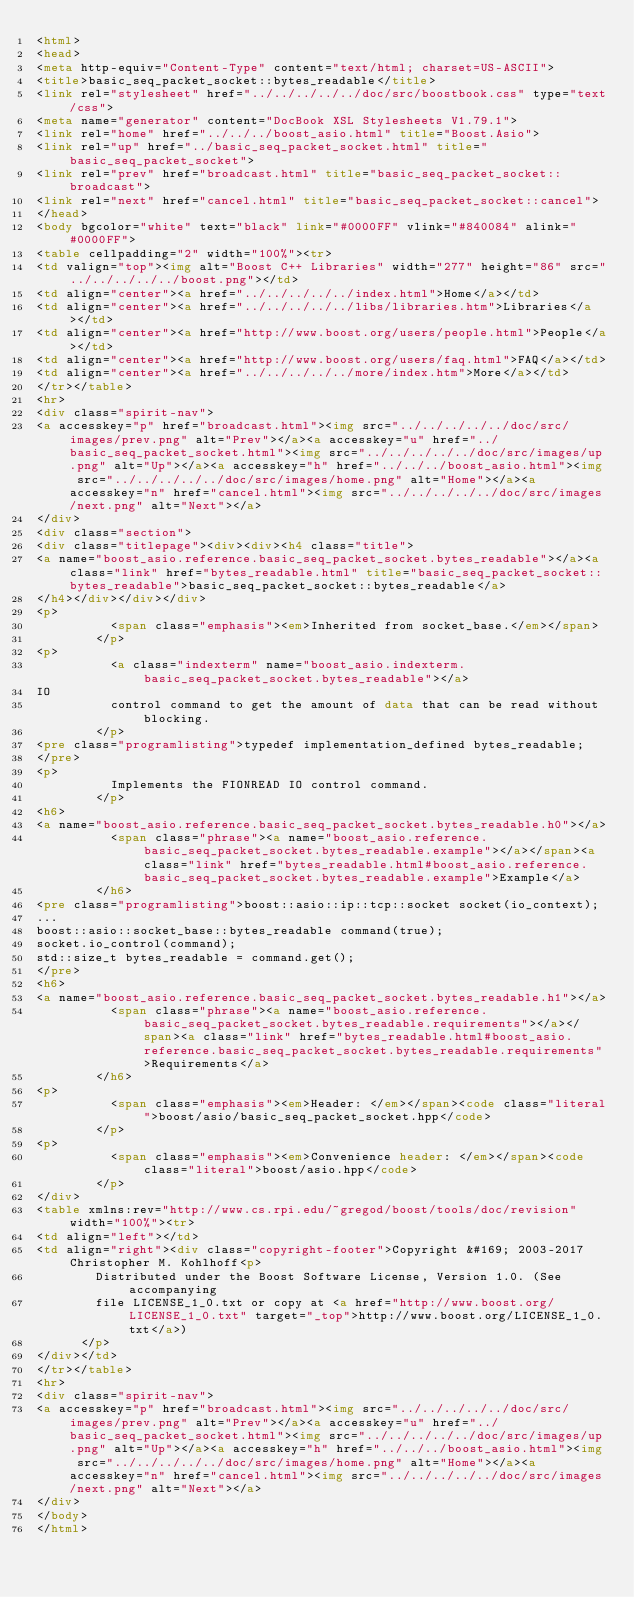<code> <loc_0><loc_0><loc_500><loc_500><_HTML_><html>
<head>
<meta http-equiv="Content-Type" content="text/html; charset=US-ASCII">
<title>basic_seq_packet_socket::bytes_readable</title>
<link rel="stylesheet" href="../../../../../doc/src/boostbook.css" type="text/css">
<meta name="generator" content="DocBook XSL Stylesheets V1.79.1">
<link rel="home" href="../../../boost_asio.html" title="Boost.Asio">
<link rel="up" href="../basic_seq_packet_socket.html" title="basic_seq_packet_socket">
<link rel="prev" href="broadcast.html" title="basic_seq_packet_socket::broadcast">
<link rel="next" href="cancel.html" title="basic_seq_packet_socket::cancel">
</head>
<body bgcolor="white" text="black" link="#0000FF" vlink="#840084" alink="#0000FF">
<table cellpadding="2" width="100%"><tr>
<td valign="top"><img alt="Boost C++ Libraries" width="277" height="86" src="../../../../../boost.png"></td>
<td align="center"><a href="../../../../../index.html">Home</a></td>
<td align="center"><a href="../../../../../libs/libraries.htm">Libraries</a></td>
<td align="center"><a href="http://www.boost.org/users/people.html">People</a></td>
<td align="center"><a href="http://www.boost.org/users/faq.html">FAQ</a></td>
<td align="center"><a href="../../../../../more/index.htm">More</a></td>
</tr></table>
<hr>
<div class="spirit-nav">
<a accesskey="p" href="broadcast.html"><img src="../../../../../doc/src/images/prev.png" alt="Prev"></a><a accesskey="u" href="../basic_seq_packet_socket.html"><img src="../../../../../doc/src/images/up.png" alt="Up"></a><a accesskey="h" href="../../../boost_asio.html"><img src="../../../../../doc/src/images/home.png" alt="Home"></a><a accesskey="n" href="cancel.html"><img src="../../../../../doc/src/images/next.png" alt="Next"></a>
</div>
<div class="section">
<div class="titlepage"><div><div><h4 class="title">
<a name="boost_asio.reference.basic_seq_packet_socket.bytes_readable"></a><a class="link" href="bytes_readable.html" title="basic_seq_packet_socket::bytes_readable">basic_seq_packet_socket::bytes_readable</a>
</h4></div></div></div>
<p>
          <span class="emphasis"><em>Inherited from socket_base.</em></span>
        </p>
<p>
          <a class="indexterm" name="boost_asio.indexterm.basic_seq_packet_socket.bytes_readable"></a> 
IO
          control command to get the amount of data that can be read without blocking.
        </p>
<pre class="programlisting">typedef implementation_defined bytes_readable;
</pre>
<p>
          Implements the FIONREAD IO control command.
        </p>
<h6>
<a name="boost_asio.reference.basic_seq_packet_socket.bytes_readable.h0"></a>
          <span class="phrase"><a name="boost_asio.reference.basic_seq_packet_socket.bytes_readable.example"></a></span><a class="link" href="bytes_readable.html#boost_asio.reference.basic_seq_packet_socket.bytes_readable.example">Example</a>
        </h6>
<pre class="programlisting">boost::asio::ip::tcp::socket socket(io_context);
...
boost::asio::socket_base::bytes_readable command(true);
socket.io_control(command);
std::size_t bytes_readable = command.get();
</pre>
<h6>
<a name="boost_asio.reference.basic_seq_packet_socket.bytes_readable.h1"></a>
          <span class="phrase"><a name="boost_asio.reference.basic_seq_packet_socket.bytes_readable.requirements"></a></span><a class="link" href="bytes_readable.html#boost_asio.reference.basic_seq_packet_socket.bytes_readable.requirements">Requirements</a>
        </h6>
<p>
          <span class="emphasis"><em>Header: </em></span><code class="literal">boost/asio/basic_seq_packet_socket.hpp</code>
        </p>
<p>
          <span class="emphasis"><em>Convenience header: </em></span><code class="literal">boost/asio.hpp</code>
        </p>
</div>
<table xmlns:rev="http://www.cs.rpi.edu/~gregod/boost/tools/doc/revision" width="100%"><tr>
<td align="left"></td>
<td align="right"><div class="copyright-footer">Copyright &#169; 2003-2017 Christopher M. Kohlhoff<p>
        Distributed under the Boost Software License, Version 1.0. (See accompanying
        file LICENSE_1_0.txt or copy at <a href="http://www.boost.org/LICENSE_1_0.txt" target="_top">http://www.boost.org/LICENSE_1_0.txt</a>)
      </p>
</div></td>
</tr></table>
<hr>
<div class="spirit-nav">
<a accesskey="p" href="broadcast.html"><img src="../../../../../doc/src/images/prev.png" alt="Prev"></a><a accesskey="u" href="../basic_seq_packet_socket.html"><img src="../../../../../doc/src/images/up.png" alt="Up"></a><a accesskey="h" href="../../../boost_asio.html"><img src="../../../../../doc/src/images/home.png" alt="Home"></a><a accesskey="n" href="cancel.html"><img src="../../../../../doc/src/images/next.png" alt="Next"></a>
</div>
</body>
</html>
</code> 